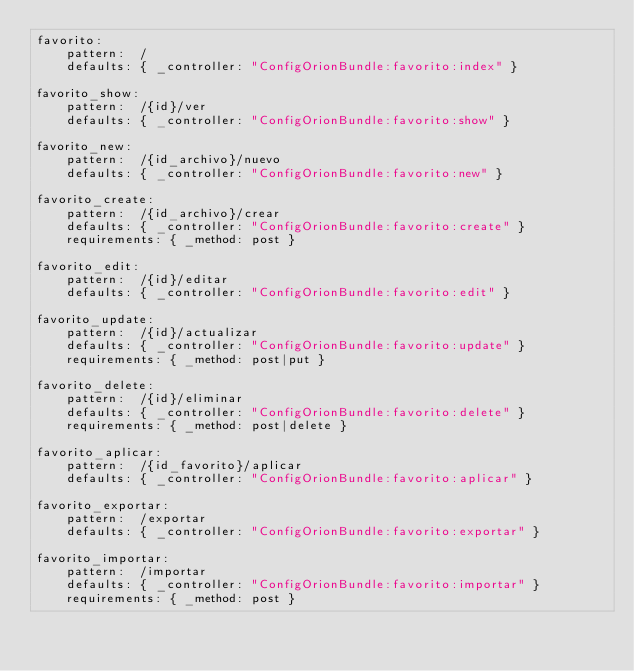Convert code to text. <code><loc_0><loc_0><loc_500><loc_500><_YAML_>favorito:
    pattern:  /
    defaults: { _controller: "ConfigOrionBundle:favorito:index" }

favorito_show:
    pattern:  /{id}/ver
    defaults: { _controller: "ConfigOrionBundle:favorito:show" }

favorito_new:
    pattern:  /{id_archivo}/nuevo
    defaults: { _controller: "ConfigOrionBundle:favorito:new" }

favorito_create:
    pattern:  /{id_archivo}/crear
    defaults: { _controller: "ConfigOrionBundle:favorito:create" }
    requirements: { _method: post }

favorito_edit:
    pattern:  /{id}/editar
    defaults: { _controller: "ConfigOrionBundle:favorito:edit" }

favorito_update:
    pattern:  /{id}/actualizar
    defaults: { _controller: "ConfigOrionBundle:favorito:update" }
    requirements: { _method: post|put }

favorito_delete:
    pattern:  /{id}/eliminar
    defaults: { _controller: "ConfigOrionBundle:favorito:delete" }
    requirements: { _method: post|delete }   

favorito_aplicar:
    pattern:  /{id_favorito}/aplicar
    defaults: { _controller: "ConfigOrionBundle:favorito:aplicar" }

favorito_exportar:
    pattern:  /exportar
    defaults: { _controller: "ConfigOrionBundle:favorito:exportar" }

favorito_importar:
    pattern:  /importar
    defaults: { _controller: "ConfigOrionBundle:favorito:importar" }
    requirements: { _method: post }
</code> 